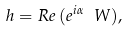Convert formula to latex. <formula><loc_0><loc_0><loc_500><loc_500>h = R e \, ( e ^ { i \alpha } \ W ) ,</formula> 